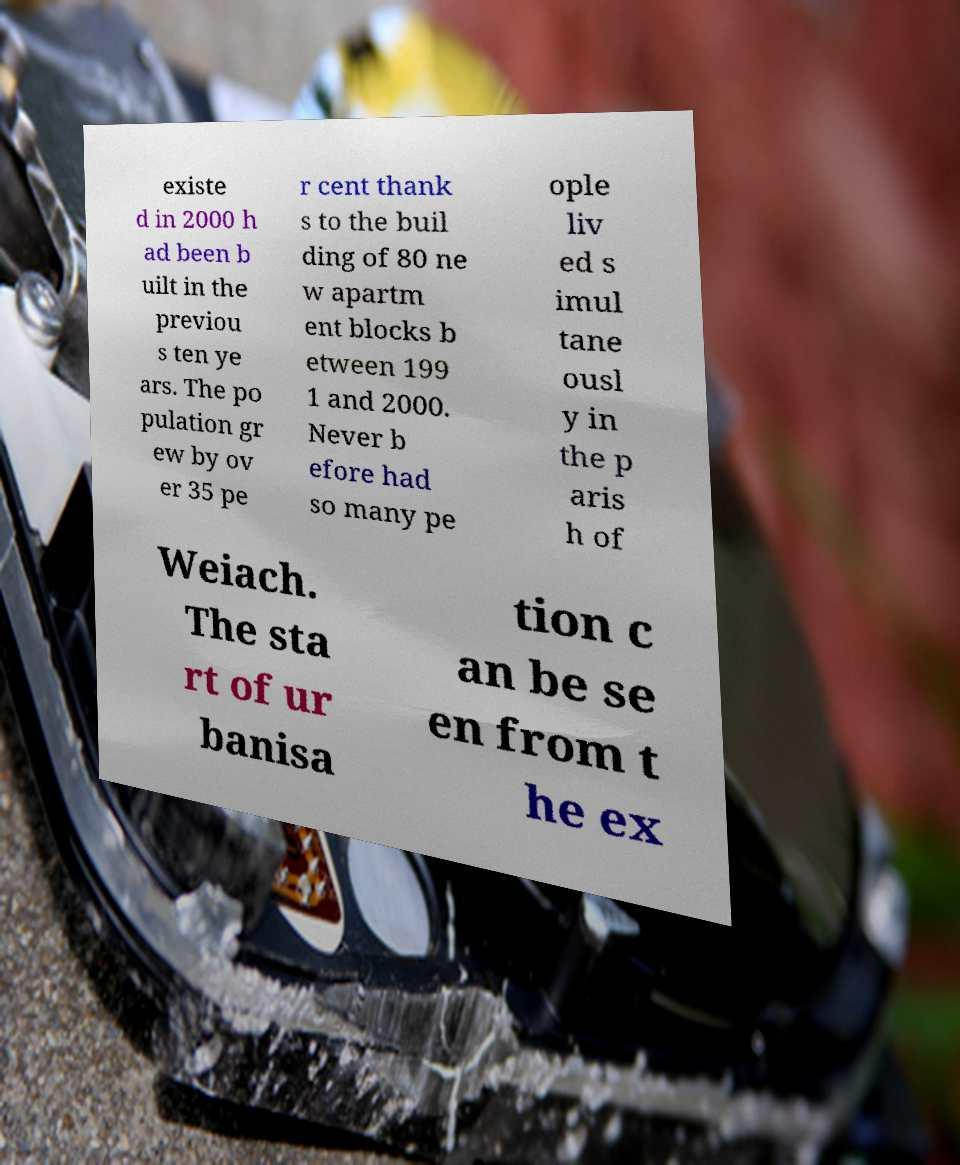For documentation purposes, I need the text within this image transcribed. Could you provide that? existe d in 2000 h ad been b uilt in the previou s ten ye ars. The po pulation gr ew by ov er 35 pe r cent thank s to the buil ding of 80 ne w apartm ent blocks b etween 199 1 and 2000. Never b efore had so many pe ople liv ed s imul tane ousl y in the p aris h of Weiach. The sta rt of ur banisa tion c an be se en from t he ex 